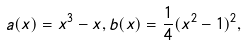<formula> <loc_0><loc_0><loc_500><loc_500>a ( x ) = x ^ { 3 } - x , b ( x ) = \frac { 1 } { 4 } ( x ^ { 2 } - 1 ) ^ { 2 } ,</formula> 